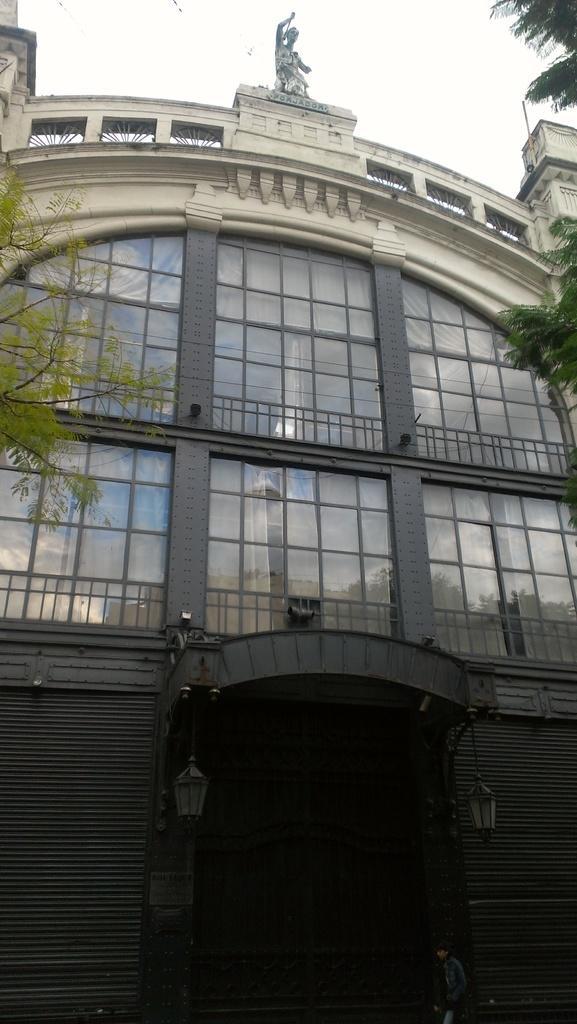Can you describe this image briefly? In the foreground of this image, there is a building and on either side, there are trees. On the top, there is the sky. 